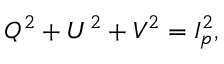<formula> <loc_0><loc_0><loc_500><loc_500>Q ^ { 2 } + U ^ { 2 } + V ^ { 2 } = I _ { p } ^ { 2 } ,</formula> 